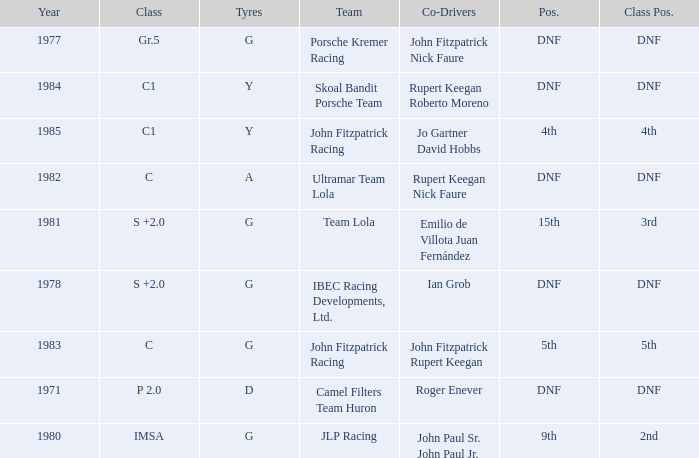Could you parse the entire table as a dict? {'header': ['Year', 'Class', 'Tyres', 'Team', 'Co-Drivers', 'Pos.', 'Class Pos.'], 'rows': [['1977', 'Gr.5', 'G', 'Porsche Kremer Racing', 'John Fitzpatrick Nick Faure', 'DNF', 'DNF'], ['1984', 'C1', 'Y', 'Skoal Bandit Porsche Team', 'Rupert Keegan Roberto Moreno', 'DNF', 'DNF'], ['1985', 'C1', 'Y', 'John Fitzpatrick Racing', 'Jo Gartner David Hobbs', '4th', '4th'], ['1982', 'C', 'A', 'Ultramar Team Lola', 'Rupert Keegan Nick Faure', 'DNF', 'DNF'], ['1981', 'S +2.0', 'G', 'Team Lola', 'Emilio de Villota Juan Fernández', '15th', '3rd'], ['1978', 'S +2.0', 'G', 'IBEC Racing Developments, Ltd.', 'Ian Grob', 'DNF', 'DNF'], ['1983', 'C', 'G', 'John Fitzpatrick Racing', 'John Fitzpatrick Rupert Keegan', '5th', '5th'], ['1971', 'P 2.0', 'D', 'Camel Filters Team Huron', 'Roger Enever', 'DNF', 'DNF'], ['1980', 'IMSA', 'G', 'JLP Racing', 'John Paul Sr. John Paul Jr.', '9th', '2nd']]} Which tires were in Class C in years before 1983? A. 